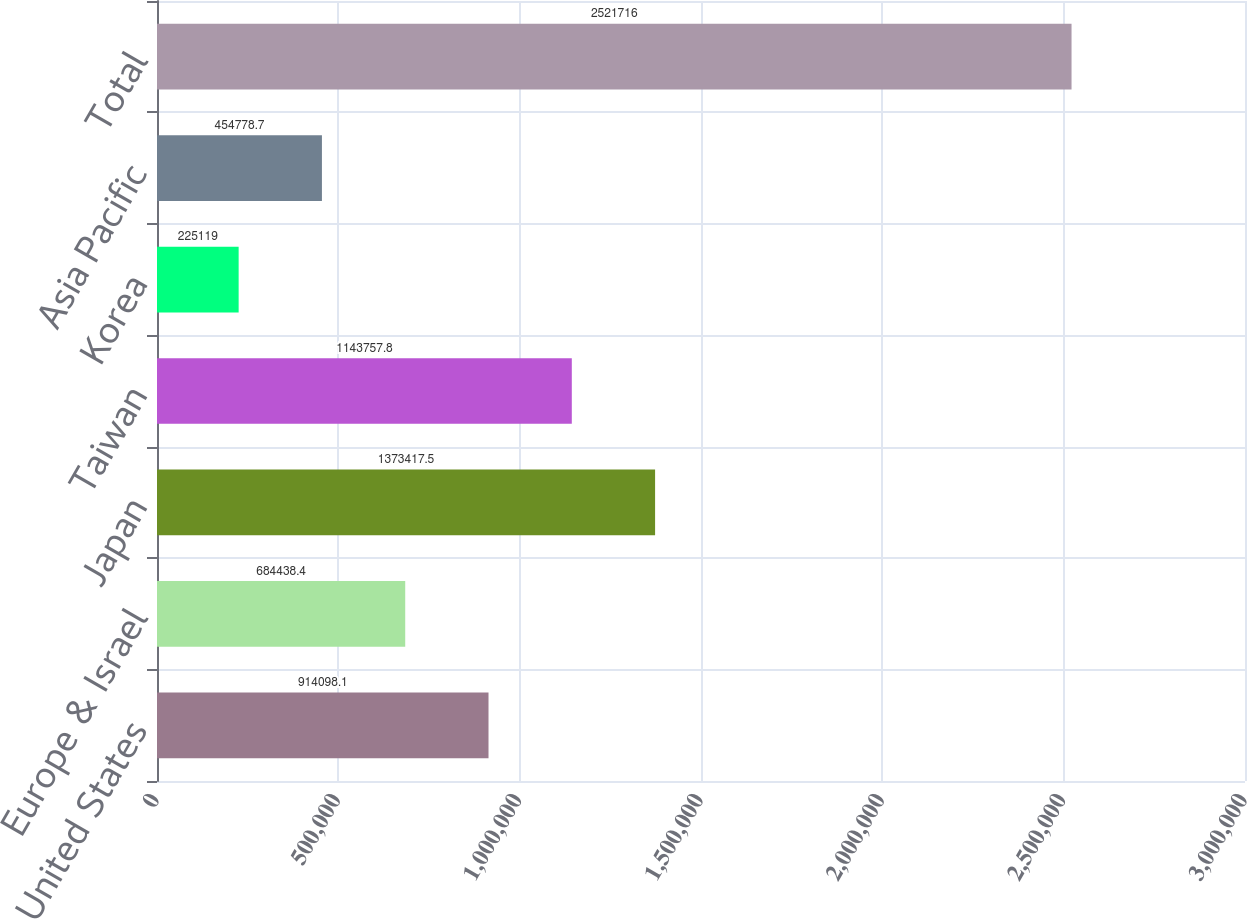Convert chart. <chart><loc_0><loc_0><loc_500><loc_500><bar_chart><fcel>United States<fcel>Europe & Israel<fcel>Japan<fcel>Taiwan<fcel>Korea<fcel>Asia Pacific<fcel>Total<nl><fcel>914098<fcel>684438<fcel>1.37342e+06<fcel>1.14376e+06<fcel>225119<fcel>454779<fcel>2.52172e+06<nl></chart> 